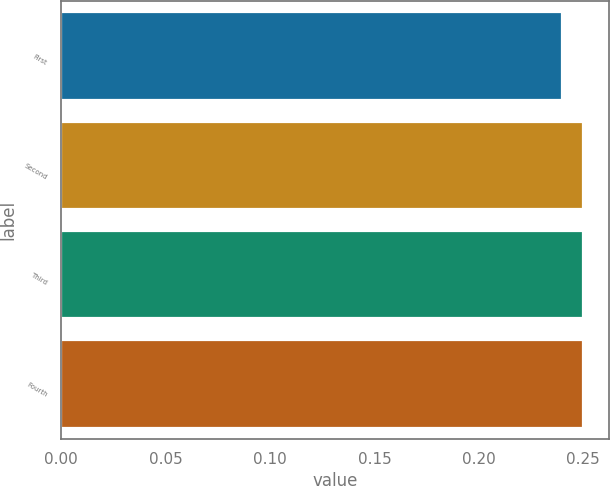Convert chart. <chart><loc_0><loc_0><loc_500><loc_500><bar_chart><fcel>First<fcel>Second<fcel>Third<fcel>Fourth<nl><fcel>0.24<fcel>0.25<fcel>0.25<fcel>0.25<nl></chart> 